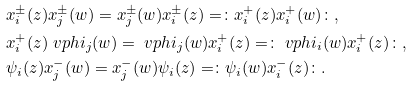<formula> <loc_0><loc_0><loc_500><loc_500>& x _ { i } ^ { \pm } ( z ) x _ { j } ^ { \pm } ( w ) = x _ { j } ^ { \pm } ( w ) x _ { i } ^ { \pm } ( z ) = \colon x _ { i } ^ { + } ( z ) x _ { i } ^ { + } ( w ) \colon , \\ & x _ { i } ^ { + } ( z ) \ v p h i _ { j } ( w ) = \ v p h i _ { j } ( w ) x _ { i } ^ { + } ( z ) = \colon \ v p h i _ { i } ( w ) x _ { i } ^ { + } ( z ) \colon , \\ & \psi _ { i } ( z ) x _ { j } ^ { - } ( w ) = x _ { j } ^ { - } ( w ) \psi _ { i } ( z ) = \colon \psi _ { i } ( w ) x _ { i } ^ { - } ( z ) \colon .</formula> 